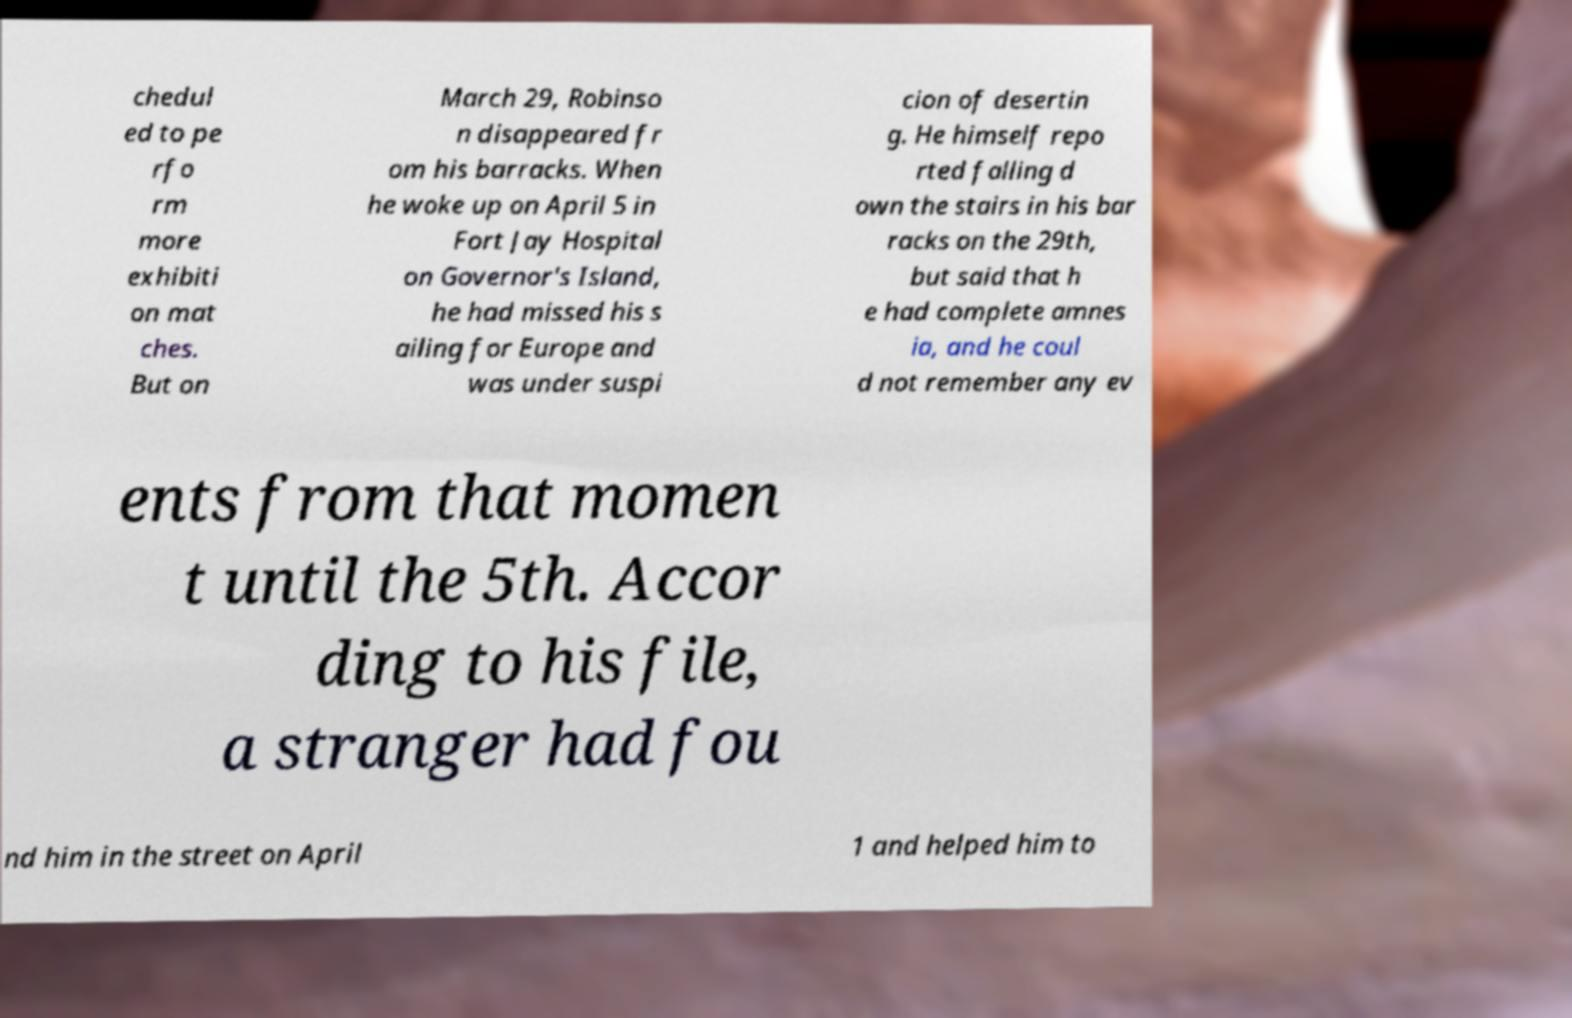Can you accurately transcribe the text from the provided image for me? chedul ed to pe rfo rm more exhibiti on mat ches. But on March 29, Robinso n disappeared fr om his barracks. When he woke up on April 5 in Fort Jay Hospital on Governor's Island, he had missed his s ailing for Europe and was under suspi cion of desertin g. He himself repo rted falling d own the stairs in his bar racks on the 29th, but said that h e had complete amnes ia, and he coul d not remember any ev ents from that momen t until the 5th. Accor ding to his file, a stranger had fou nd him in the street on April 1 and helped him to 